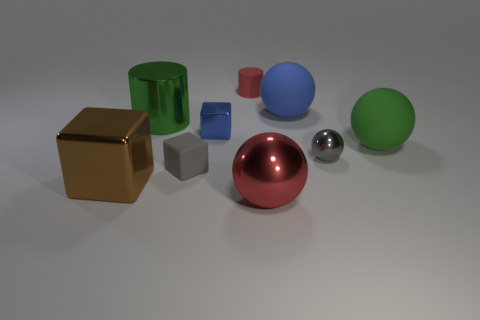Subtract all big blue rubber balls. How many balls are left? 3 Subtract all red balls. How many balls are left? 3 Subtract 2 balls. How many balls are left? 2 Add 1 brown metal objects. How many objects exist? 10 Subtract all brown balls. Subtract all green cubes. How many balls are left? 4 Subtract all balls. How many objects are left? 5 Subtract all brown things. Subtract all small gray rubber cubes. How many objects are left? 7 Add 6 large brown blocks. How many large brown blocks are left? 7 Add 9 cyan cubes. How many cyan cubes exist? 9 Subtract 0 green blocks. How many objects are left? 9 